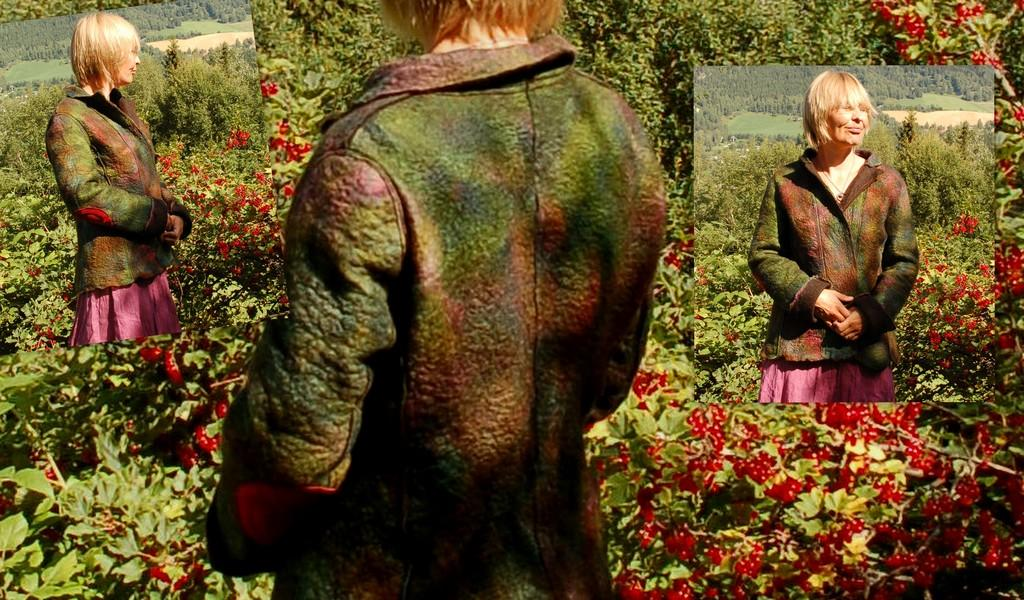What type of image is being shown? The image is an edited picture. Who or what is the main subject in the image? There is a woman in the image. What other elements can be seen in the image? There are plants, fruits, and trees in the image. What is the purpose of the hour in the image? There is no hour present in the image, as it only features a woman, plants, fruits, and trees. 